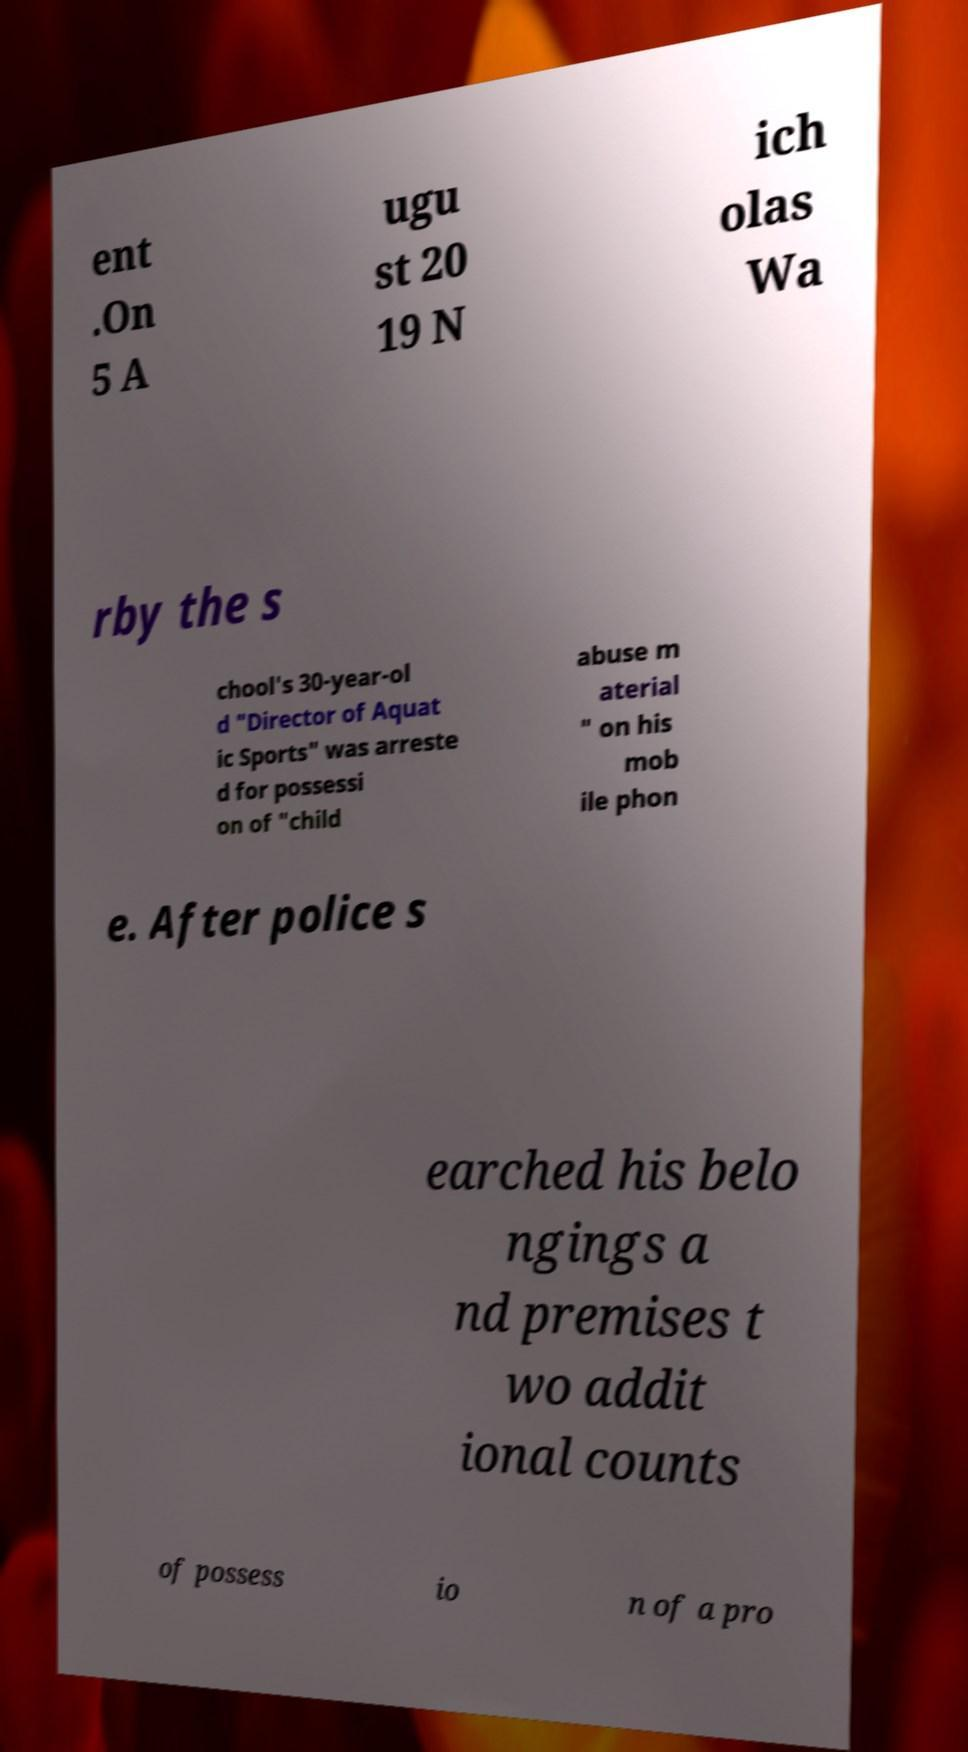Please identify and transcribe the text found in this image. ent .On 5 A ugu st 20 19 N ich olas Wa rby the s chool's 30-year-ol d "Director of Aquat ic Sports" was arreste d for possessi on of "child abuse m aterial " on his mob ile phon e. After police s earched his belo ngings a nd premises t wo addit ional counts of possess io n of a pro 